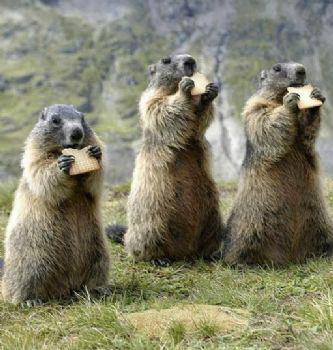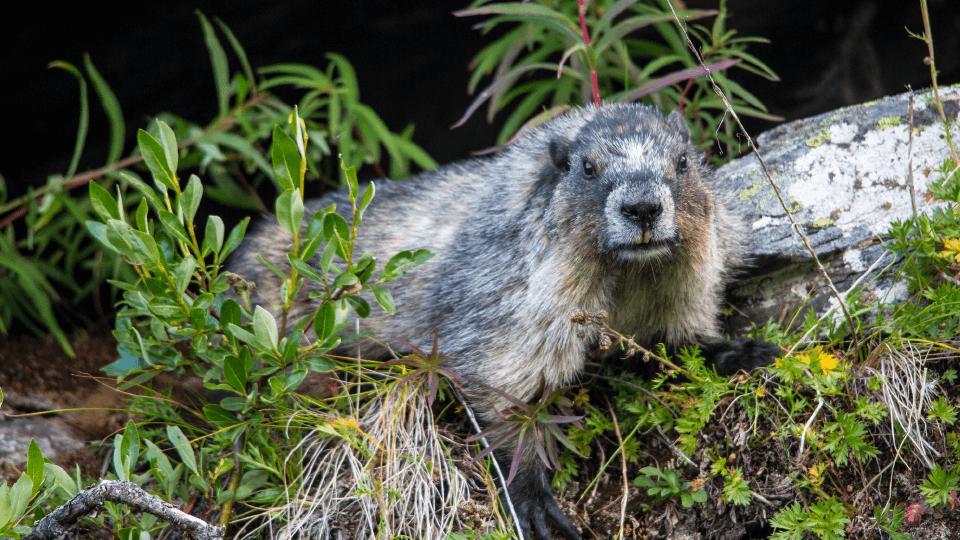The first image is the image on the left, the second image is the image on the right. Given the left and right images, does the statement "Each image contains at least three marmots in a close grouping." hold true? Answer yes or no. No. 